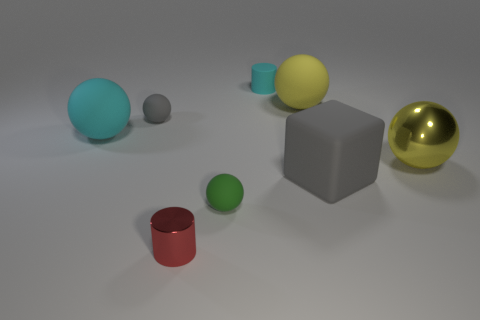Subtract all tiny gray spheres. How many spheres are left? 4 Add 2 metallic spheres. How many objects exist? 10 Subtract 0 yellow blocks. How many objects are left? 8 Subtract all cubes. How many objects are left? 7 Subtract 1 spheres. How many spheres are left? 4 Subtract all purple balls. Subtract all red cylinders. How many balls are left? 5 Subtract all cyan balls. How many blue blocks are left? 0 Subtract all small blue rubber blocks. Subtract all big yellow matte things. How many objects are left? 7 Add 8 large gray matte cubes. How many large gray matte cubes are left? 9 Add 2 tiny red cylinders. How many tiny red cylinders exist? 3 